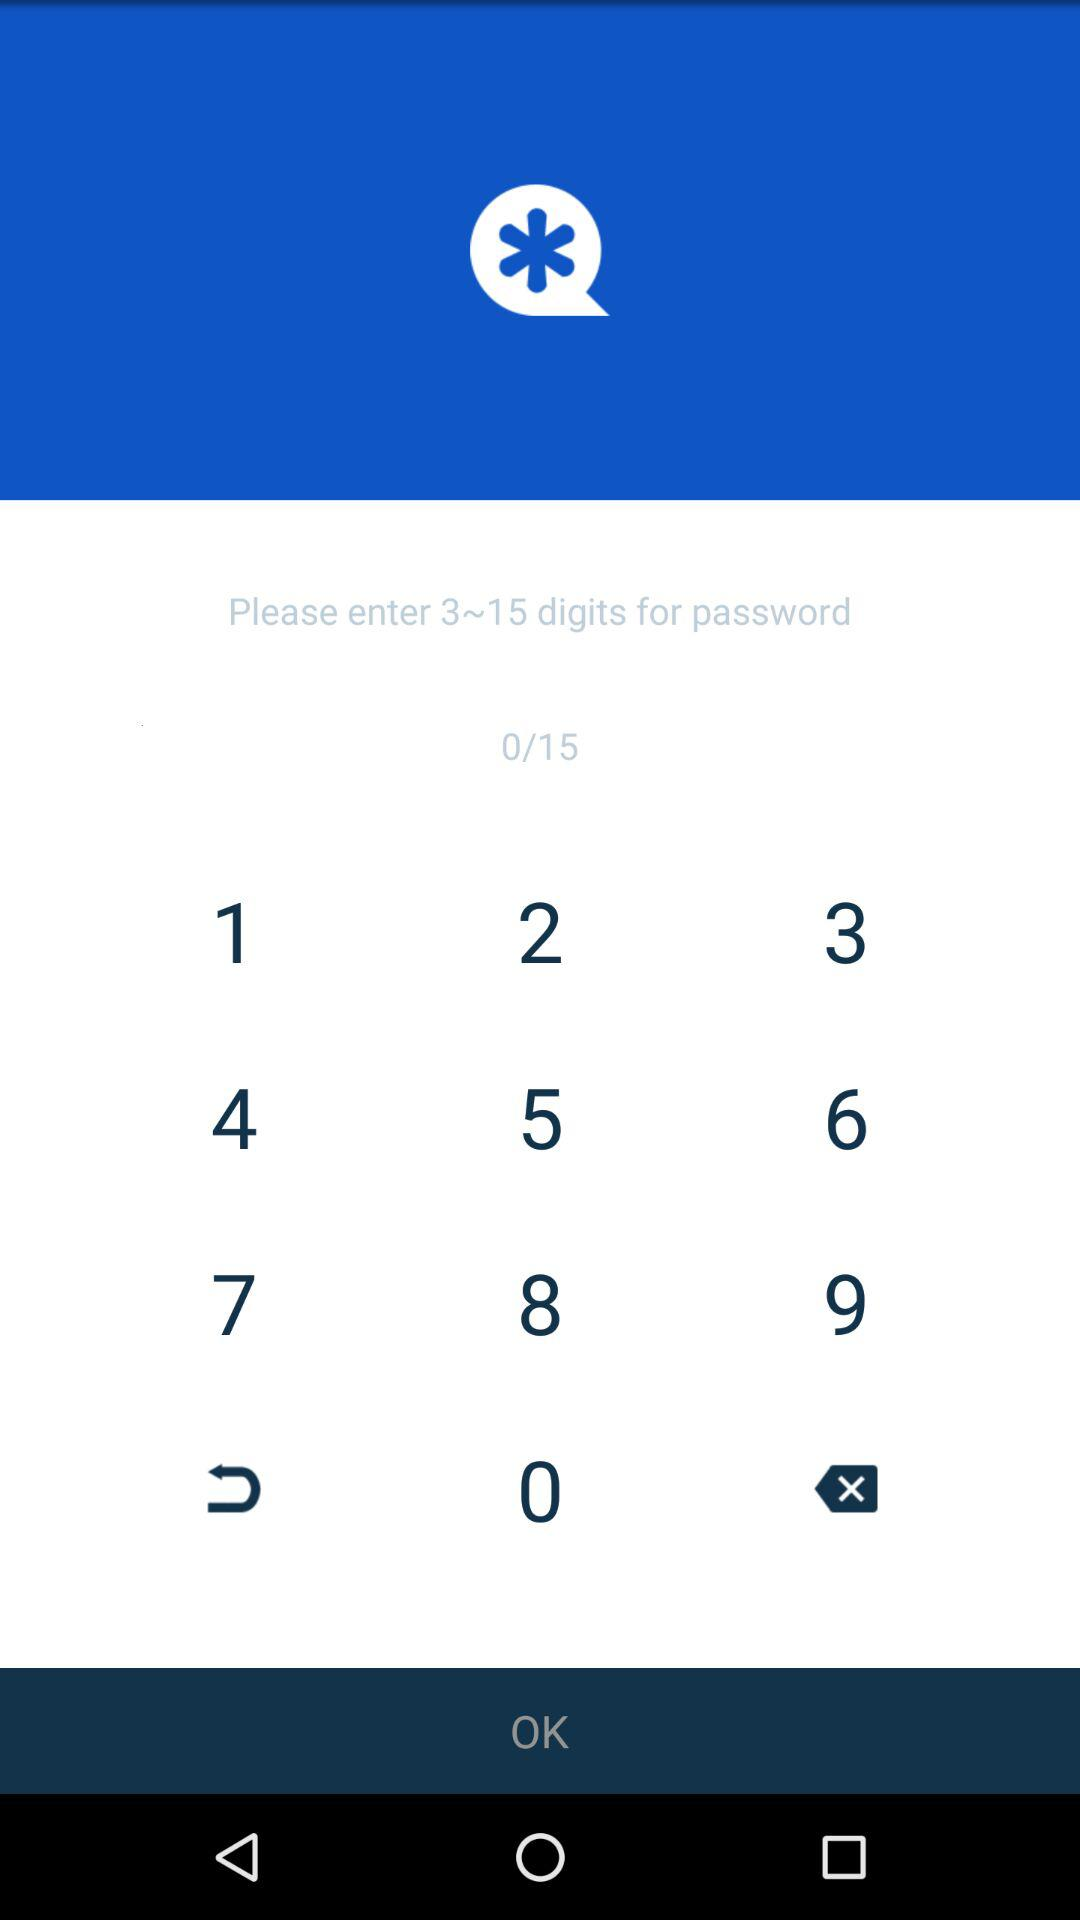How many digits have to be entered for a password? You have to enter between 3 to 15 digits. 